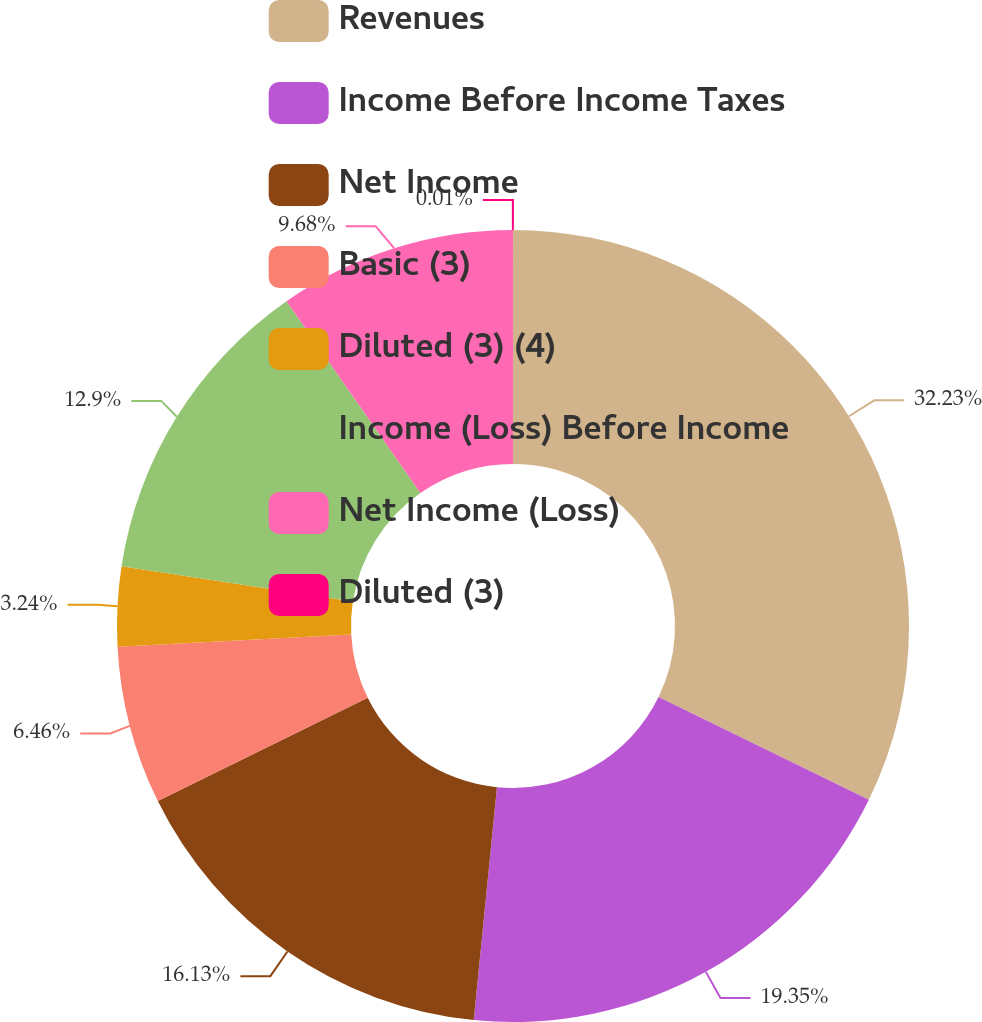Convert chart. <chart><loc_0><loc_0><loc_500><loc_500><pie_chart><fcel>Revenues<fcel>Income Before Income Taxes<fcel>Net Income<fcel>Basic (3)<fcel>Diluted (3) (4)<fcel>Income (Loss) Before Income<fcel>Net Income (Loss)<fcel>Diluted (3)<nl><fcel>32.23%<fcel>19.35%<fcel>16.13%<fcel>6.46%<fcel>3.24%<fcel>12.9%<fcel>9.68%<fcel>0.01%<nl></chart> 